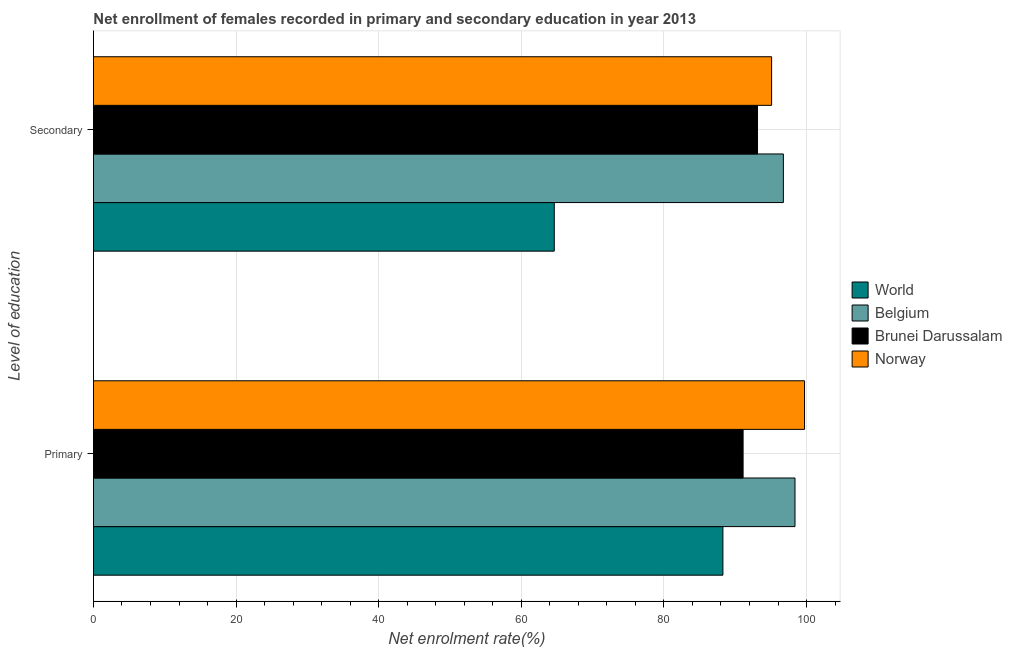Are the number of bars per tick equal to the number of legend labels?
Offer a terse response. Yes. What is the label of the 2nd group of bars from the top?
Keep it short and to the point. Primary. What is the enrollment rate in primary education in Belgium?
Your response must be concise. 98.38. Across all countries, what is the maximum enrollment rate in secondary education?
Make the answer very short. 96.75. Across all countries, what is the minimum enrollment rate in secondary education?
Offer a very short reply. 64.62. In which country was the enrollment rate in primary education maximum?
Provide a short and direct response. Norway. In which country was the enrollment rate in secondary education minimum?
Offer a terse response. World. What is the total enrollment rate in secondary education in the graph?
Your response must be concise. 349.6. What is the difference between the enrollment rate in primary education in Norway and that in World?
Offer a very short reply. 11.45. What is the difference between the enrollment rate in primary education in Brunei Darussalam and the enrollment rate in secondary education in Norway?
Your answer should be compact. -4. What is the average enrollment rate in secondary education per country?
Your answer should be very brief. 87.4. What is the difference between the enrollment rate in primary education and enrollment rate in secondary education in Brunei Darussalam?
Offer a very short reply. -2.02. In how many countries, is the enrollment rate in secondary education greater than 52 %?
Offer a terse response. 4. What is the ratio of the enrollment rate in secondary education in World to that in Belgium?
Make the answer very short. 0.67. What does the 2nd bar from the top in Primary represents?
Offer a terse response. Brunei Darussalam. What does the 2nd bar from the bottom in Secondary represents?
Keep it short and to the point. Belgium. Are all the bars in the graph horizontal?
Offer a terse response. Yes. What is the difference between two consecutive major ticks on the X-axis?
Provide a short and direct response. 20. Are the values on the major ticks of X-axis written in scientific E-notation?
Keep it short and to the point. No. Does the graph contain any zero values?
Provide a succinct answer. No. Where does the legend appear in the graph?
Your answer should be very brief. Center right. What is the title of the graph?
Your response must be concise. Net enrollment of females recorded in primary and secondary education in year 2013. Does "Benin" appear as one of the legend labels in the graph?
Offer a terse response. No. What is the label or title of the X-axis?
Your answer should be compact. Net enrolment rate(%). What is the label or title of the Y-axis?
Make the answer very short. Level of education. What is the Net enrolment rate(%) of World in Primary?
Make the answer very short. 88.27. What is the Net enrolment rate(%) of Belgium in Primary?
Your answer should be very brief. 98.38. What is the Net enrolment rate(%) in Brunei Darussalam in Primary?
Provide a succinct answer. 91.1. What is the Net enrolment rate(%) in Norway in Primary?
Offer a very short reply. 99.72. What is the Net enrolment rate(%) of World in Secondary?
Keep it short and to the point. 64.62. What is the Net enrolment rate(%) in Belgium in Secondary?
Make the answer very short. 96.75. What is the Net enrolment rate(%) of Brunei Darussalam in Secondary?
Your answer should be compact. 93.13. What is the Net enrolment rate(%) of Norway in Secondary?
Give a very brief answer. 95.1. Across all Level of education, what is the maximum Net enrolment rate(%) of World?
Offer a very short reply. 88.27. Across all Level of education, what is the maximum Net enrolment rate(%) of Belgium?
Your response must be concise. 98.38. Across all Level of education, what is the maximum Net enrolment rate(%) in Brunei Darussalam?
Your answer should be compact. 93.13. Across all Level of education, what is the maximum Net enrolment rate(%) of Norway?
Provide a succinct answer. 99.72. Across all Level of education, what is the minimum Net enrolment rate(%) in World?
Your answer should be compact. 64.62. Across all Level of education, what is the minimum Net enrolment rate(%) in Belgium?
Give a very brief answer. 96.75. Across all Level of education, what is the minimum Net enrolment rate(%) in Brunei Darussalam?
Ensure brevity in your answer.  91.1. Across all Level of education, what is the minimum Net enrolment rate(%) of Norway?
Ensure brevity in your answer.  95.1. What is the total Net enrolment rate(%) of World in the graph?
Your answer should be compact. 152.9. What is the total Net enrolment rate(%) in Belgium in the graph?
Your answer should be very brief. 195.14. What is the total Net enrolment rate(%) in Brunei Darussalam in the graph?
Your response must be concise. 184.23. What is the total Net enrolment rate(%) of Norway in the graph?
Provide a short and direct response. 194.82. What is the difference between the Net enrolment rate(%) in World in Primary and that in Secondary?
Your answer should be very brief. 23.65. What is the difference between the Net enrolment rate(%) of Belgium in Primary and that in Secondary?
Keep it short and to the point. 1.63. What is the difference between the Net enrolment rate(%) of Brunei Darussalam in Primary and that in Secondary?
Your answer should be very brief. -2.02. What is the difference between the Net enrolment rate(%) of Norway in Primary and that in Secondary?
Give a very brief answer. 4.62. What is the difference between the Net enrolment rate(%) of World in Primary and the Net enrolment rate(%) of Belgium in Secondary?
Your answer should be very brief. -8.48. What is the difference between the Net enrolment rate(%) of World in Primary and the Net enrolment rate(%) of Brunei Darussalam in Secondary?
Your answer should be compact. -4.85. What is the difference between the Net enrolment rate(%) in World in Primary and the Net enrolment rate(%) in Norway in Secondary?
Ensure brevity in your answer.  -6.83. What is the difference between the Net enrolment rate(%) in Belgium in Primary and the Net enrolment rate(%) in Brunei Darussalam in Secondary?
Keep it short and to the point. 5.26. What is the difference between the Net enrolment rate(%) of Belgium in Primary and the Net enrolment rate(%) of Norway in Secondary?
Ensure brevity in your answer.  3.28. What is the difference between the Net enrolment rate(%) in Brunei Darussalam in Primary and the Net enrolment rate(%) in Norway in Secondary?
Ensure brevity in your answer.  -4. What is the average Net enrolment rate(%) of World per Level of education?
Ensure brevity in your answer.  76.45. What is the average Net enrolment rate(%) in Belgium per Level of education?
Ensure brevity in your answer.  97.57. What is the average Net enrolment rate(%) in Brunei Darussalam per Level of education?
Your answer should be compact. 92.12. What is the average Net enrolment rate(%) of Norway per Level of education?
Your response must be concise. 97.41. What is the difference between the Net enrolment rate(%) of World and Net enrolment rate(%) of Belgium in Primary?
Keep it short and to the point. -10.11. What is the difference between the Net enrolment rate(%) in World and Net enrolment rate(%) in Brunei Darussalam in Primary?
Offer a terse response. -2.83. What is the difference between the Net enrolment rate(%) of World and Net enrolment rate(%) of Norway in Primary?
Offer a terse response. -11.45. What is the difference between the Net enrolment rate(%) of Belgium and Net enrolment rate(%) of Brunei Darussalam in Primary?
Offer a very short reply. 7.28. What is the difference between the Net enrolment rate(%) of Belgium and Net enrolment rate(%) of Norway in Primary?
Ensure brevity in your answer.  -1.34. What is the difference between the Net enrolment rate(%) of Brunei Darussalam and Net enrolment rate(%) of Norway in Primary?
Your response must be concise. -8.62. What is the difference between the Net enrolment rate(%) of World and Net enrolment rate(%) of Belgium in Secondary?
Offer a very short reply. -32.13. What is the difference between the Net enrolment rate(%) of World and Net enrolment rate(%) of Brunei Darussalam in Secondary?
Provide a succinct answer. -28.5. What is the difference between the Net enrolment rate(%) of World and Net enrolment rate(%) of Norway in Secondary?
Offer a very short reply. -30.48. What is the difference between the Net enrolment rate(%) of Belgium and Net enrolment rate(%) of Brunei Darussalam in Secondary?
Give a very brief answer. 3.63. What is the difference between the Net enrolment rate(%) in Belgium and Net enrolment rate(%) in Norway in Secondary?
Make the answer very short. 1.65. What is the difference between the Net enrolment rate(%) of Brunei Darussalam and Net enrolment rate(%) of Norway in Secondary?
Ensure brevity in your answer.  -1.98. What is the ratio of the Net enrolment rate(%) of World in Primary to that in Secondary?
Offer a terse response. 1.37. What is the ratio of the Net enrolment rate(%) of Belgium in Primary to that in Secondary?
Your answer should be very brief. 1.02. What is the ratio of the Net enrolment rate(%) in Brunei Darussalam in Primary to that in Secondary?
Your response must be concise. 0.98. What is the ratio of the Net enrolment rate(%) in Norway in Primary to that in Secondary?
Your answer should be very brief. 1.05. What is the difference between the highest and the second highest Net enrolment rate(%) in World?
Offer a terse response. 23.65. What is the difference between the highest and the second highest Net enrolment rate(%) in Belgium?
Your answer should be very brief. 1.63. What is the difference between the highest and the second highest Net enrolment rate(%) in Brunei Darussalam?
Your answer should be very brief. 2.02. What is the difference between the highest and the second highest Net enrolment rate(%) in Norway?
Your response must be concise. 4.62. What is the difference between the highest and the lowest Net enrolment rate(%) in World?
Give a very brief answer. 23.65. What is the difference between the highest and the lowest Net enrolment rate(%) in Belgium?
Your response must be concise. 1.63. What is the difference between the highest and the lowest Net enrolment rate(%) of Brunei Darussalam?
Your response must be concise. 2.02. What is the difference between the highest and the lowest Net enrolment rate(%) of Norway?
Keep it short and to the point. 4.62. 